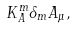<formula> <loc_0><loc_0><loc_500><loc_500>K _ { A } ^ { m } \delta _ { m } A _ { \mu } ,</formula> 